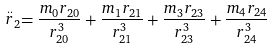Convert formula to latex. <formula><loc_0><loc_0><loc_500><loc_500>\stackrel { . . } { r } _ { 2 } = \frac { m _ { 0 } r _ { 2 0 } } { r _ { 2 0 } ^ { 3 } } + \frac { m _ { 1 } r _ { 2 1 } } { r _ { 2 1 } ^ { 3 } } + \frac { m _ { 3 } r _ { 2 3 } } { r _ { 2 3 } ^ { 3 } } + \frac { m _ { 4 } r _ { 2 4 } } { r _ { 2 4 } ^ { 3 } }</formula> 